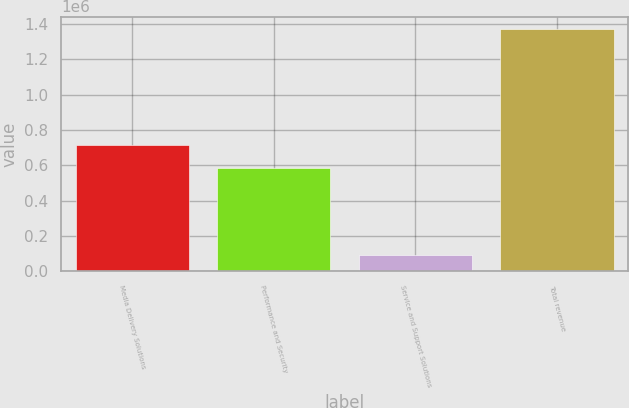Convert chart. <chart><loc_0><loc_0><loc_500><loc_500><bar_chart><fcel>Media Delivery Solutions<fcel>Performance and Security<fcel>Service and Support Solutions<fcel>Total revenue<nl><fcel>713924<fcel>585615<fcel>90857<fcel>1.37395e+06<nl></chart> 